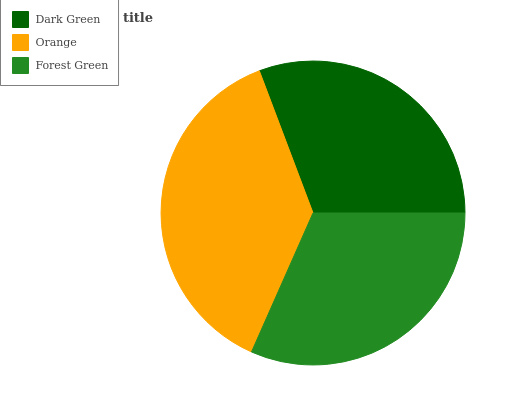Is Dark Green the minimum?
Answer yes or no. Yes. Is Orange the maximum?
Answer yes or no. Yes. Is Forest Green the minimum?
Answer yes or no. No. Is Forest Green the maximum?
Answer yes or no. No. Is Orange greater than Forest Green?
Answer yes or no. Yes. Is Forest Green less than Orange?
Answer yes or no. Yes. Is Forest Green greater than Orange?
Answer yes or no. No. Is Orange less than Forest Green?
Answer yes or no. No. Is Forest Green the high median?
Answer yes or no. Yes. Is Forest Green the low median?
Answer yes or no. Yes. Is Dark Green the high median?
Answer yes or no. No. Is Dark Green the low median?
Answer yes or no. No. 